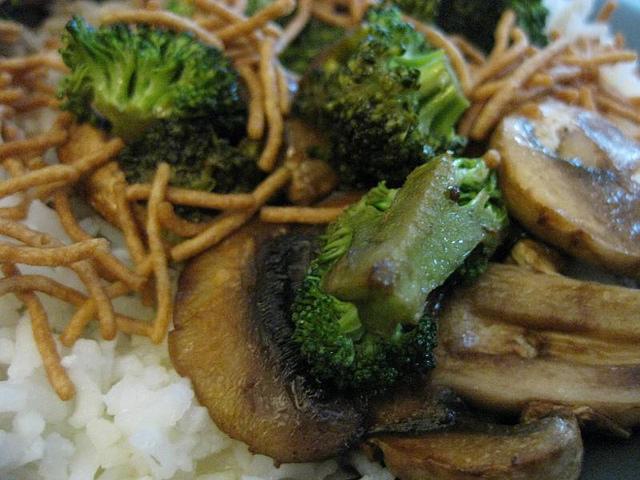How many broccolis are in the photo?
Give a very brief answer. 5. How many giraffes are eating?
Give a very brief answer. 0. 